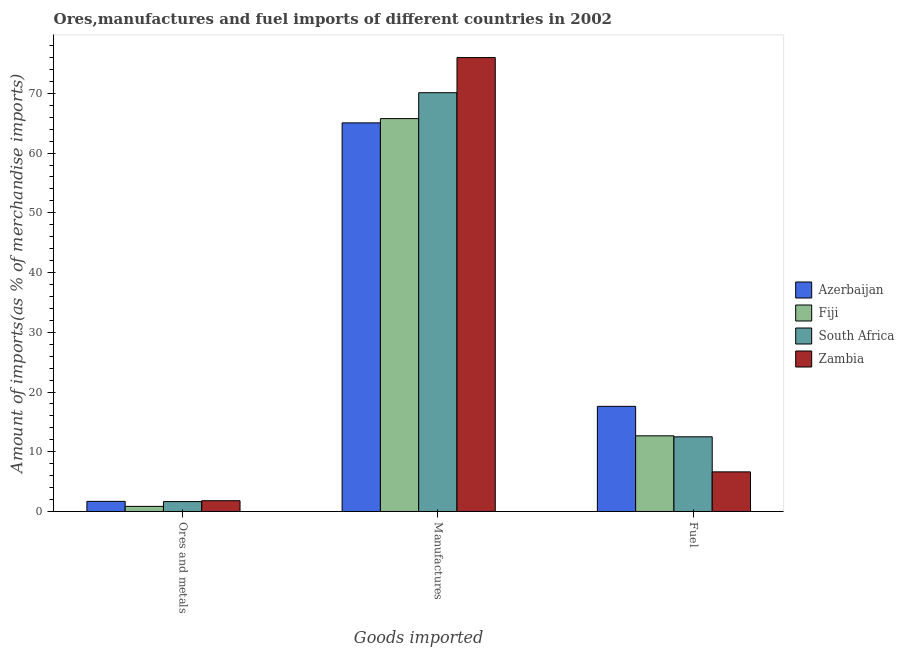How many bars are there on the 2nd tick from the left?
Provide a short and direct response. 4. How many bars are there on the 2nd tick from the right?
Provide a succinct answer. 4. What is the label of the 2nd group of bars from the left?
Your answer should be very brief. Manufactures. What is the percentage of fuel imports in Azerbaijan?
Give a very brief answer. 17.6. Across all countries, what is the maximum percentage of fuel imports?
Give a very brief answer. 17.6. Across all countries, what is the minimum percentage of manufactures imports?
Your answer should be very brief. 65.06. In which country was the percentage of fuel imports maximum?
Your answer should be compact. Azerbaijan. In which country was the percentage of manufactures imports minimum?
Offer a very short reply. Azerbaijan. What is the total percentage of fuel imports in the graph?
Give a very brief answer. 49.4. What is the difference between the percentage of ores and metals imports in Fiji and that in South Africa?
Provide a short and direct response. -0.8. What is the difference between the percentage of ores and metals imports in South Africa and the percentage of manufactures imports in Zambia?
Offer a terse response. -74.33. What is the average percentage of manufactures imports per country?
Your answer should be very brief. 69.23. What is the difference between the percentage of ores and metals imports and percentage of manufactures imports in Zambia?
Keep it short and to the point. -74.18. In how many countries, is the percentage of fuel imports greater than 28 %?
Ensure brevity in your answer.  0. What is the ratio of the percentage of ores and metals imports in Azerbaijan to that in Zambia?
Give a very brief answer. 0.94. Is the percentage of ores and metals imports in Zambia less than that in Azerbaijan?
Keep it short and to the point. No. What is the difference between the highest and the second highest percentage of fuel imports?
Offer a terse response. 4.94. What is the difference between the highest and the lowest percentage of ores and metals imports?
Your answer should be compact. 0.95. Is the sum of the percentage of ores and metals imports in Azerbaijan and Fiji greater than the maximum percentage of manufactures imports across all countries?
Offer a terse response. No. What does the 4th bar from the left in Manufactures represents?
Provide a succinct answer. Zambia. What does the 1st bar from the right in Fuel represents?
Offer a terse response. Zambia. Is it the case that in every country, the sum of the percentage of ores and metals imports and percentage of manufactures imports is greater than the percentage of fuel imports?
Provide a short and direct response. Yes. What is the difference between two consecutive major ticks on the Y-axis?
Give a very brief answer. 10. Are the values on the major ticks of Y-axis written in scientific E-notation?
Offer a terse response. No. Does the graph contain any zero values?
Offer a terse response. No. Where does the legend appear in the graph?
Give a very brief answer. Center right. How many legend labels are there?
Make the answer very short. 4. What is the title of the graph?
Offer a terse response. Ores,manufactures and fuel imports of different countries in 2002. What is the label or title of the X-axis?
Keep it short and to the point. Goods imported. What is the label or title of the Y-axis?
Offer a terse response. Amount of imports(as % of merchandise imports). What is the Amount of imports(as % of merchandise imports) of Azerbaijan in Ores and metals?
Provide a short and direct response. 1.69. What is the Amount of imports(as % of merchandise imports) of Fiji in Ores and metals?
Your response must be concise. 0.86. What is the Amount of imports(as % of merchandise imports) in South Africa in Ores and metals?
Provide a short and direct response. 1.66. What is the Amount of imports(as % of merchandise imports) in Zambia in Ores and metals?
Provide a short and direct response. 1.8. What is the Amount of imports(as % of merchandise imports) of Azerbaijan in Manufactures?
Keep it short and to the point. 65.06. What is the Amount of imports(as % of merchandise imports) in Fiji in Manufactures?
Your response must be concise. 65.77. What is the Amount of imports(as % of merchandise imports) of South Africa in Manufactures?
Your answer should be very brief. 70.1. What is the Amount of imports(as % of merchandise imports) of Zambia in Manufactures?
Your answer should be very brief. 75.99. What is the Amount of imports(as % of merchandise imports) of Azerbaijan in Fuel?
Give a very brief answer. 17.6. What is the Amount of imports(as % of merchandise imports) in Fiji in Fuel?
Make the answer very short. 12.67. What is the Amount of imports(as % of merchandise imports) in South Africa in Fuel?
Offer a very short reply. 12.5. What is the Amount of imports(as % of merchandise imports) of Zambia in Fuel?
Make the answer very short. 6.63. Across all Goods imported, what is the maximum Amount of imports(as % of merchandise imports) in Azerbaijan?
Ensure brevity in your answer.  65.06. Across all Goods imported, what is the maximum Amount of imports(as % of merchandise imports) in Fiji?
Provide a succinct answer. 65.77. Across all Goods imported, what is the maximum Amount of imports(as % of merchandise imports) in South Africa?
Keep it short and to the point. 70.1. Across all Goods imported, what is the maximum Amount of imports(as % of merchandise imports) in Zambia?
Your answer should be very brief. 75.99. Across all Goods imported, what is the minimum Amount of imports(as % of merchandise imports) of Azerbaijan?
Ensure brevity in your answer.  1.69. Across all Goods imported, what is the minimum Amount of imports(as % of merchandise imports) of Fiji?
Your answer should be compact. 0.86. Across all Goods imported, what is the minimum Amount of imports(as % of merchandise imports) of South Africa?
Ensure brevity in your answer.  1.66. Across all Goods imported, what is the minimum Amount of imports(as % of merchandise imports) of Zambia?
Ensure brevity in your answer.  1.8. What is the total Amount of imports(as % of merchandise imports) of Azerbaijan in the graph?
Offer a very short reply. 84.35. What is the total Amount of imports(as % of merchandise imports) of Fiji in the graph?
Your answer should be compact. 79.3. What is the total Amount of imports(as % of merchandise imports) in South Africa in the graph?
Offer a terse response. 84.26. What is the total Amount of imports(as % of merchandise imports) in Zambia in the graph?
Give a very brief answer. 84.42. What is the difference between the Amount of imports(as % of merchandise imports) of Azerbaijan in Ores and metals and that in Manufactures?
Provide a short and direct response. -63.36. What is the difference between the Amount of imports(as % of merchandise imports) in Fiji in Ores and metals and that in Manufactures?
Your answer should be very brief. -64.91. What is the difference between the Amount of imports(as % of merchandise imports) in South Africa in Ores and metals and that in Manufactures?
Provide a short and direct response. -68.45. What is the difference between the Amount of imports(as % of merchandise imports) in Zambia in Ores and metals and that in Manufactures?
Offer a very short reply. -74.18. What is the difference between the Amount of imports(as % of merchandise imports) of Azerbaijan in Ores and metals and that in Fuel?
Your answer should be compact. -15.91. What is the difference between the Amount of imports(as % of merchandise imports) in Fiji in Ores and metals and that in Fuel?
Keep it short and to the point. -11.81. What is the difference between the Amount of imports(as % of merchandise imports) of South Africa in Ores and metals and that in Fuel?
Make the answer very short. -10.84. What is the difference between the Amount of imports(as % of merchandise imports) of Zambia in Ores and metals and that in Fuel?
Provide a short and direct response. -4.83. What is the difference between the Amount of imports(as % of merchandise imports) of Azerbaijan in Manufactures and that in Fuel?
Your answer should be very brief. 47.45. What is the difference between the Amount of imports(as % of merchandise imports) of Fiji in Manufactures and that in Fuel?
Provide a succinct answer. 53.11. What is the difference between the Amount of imports(as % of merchandise imports) of South Africa in Manufactures and that in Fuel?
Ensure brevity in your answer.  57.6. What is the difference between the Amount of imports(as % of merchandise imports) of Zambia in Manufactures and that in Fuel?
Your answer should be very brief. 69.36. What is the difference between the Amount of imports(as % of merchandise imports) in Azerbaijan in Ores and metals and the Amount of imports(as % of merchandise imports) in Fiji in Manufactures?
Make the answer very short. -64.08. What is the difference between the Amount of imports(as % of merchandise imports) in Azerbaijan in Ores and metals and the Amount of imports(as % of merchandise imports) in South Africa in Manufactures?
Your answer should be compact. -68.41. What is the difference between the Amount of imports(as % of merchandise imports) in Azerbaijan in Ores and metals and the Amount of imports(as % of merchandise imports) in Zambia in Manufactures?
Provide a succinct answer. -74.29. What is the difference between the Amount of imports(as % of merchandise imports) of Fiji in Ores and metals and the Amount of imports(as % of merchandise imports) of South Africa in Manufactures?
Ensure brevity in your answer.  -69.25. What is the difference between the Amount of imports(as % of merchandise imports) in Fiji in Ores and metals and the Amount of imports(as % of merchandise imports) in Zambia in Manufactures?
Ensure brevity in your answer.  -75.13. What is the difference between the Amount of imports(as % of merchandise imports) of South Africa in Ores and metals and the Amount of imports(as % of merchandise imports) of Zambia in Manufactures?
Offer a very short reply. -74.33. What is the difference between the Amount of imports(as % of merchandise imports) of Azerbaijan in Ores and metals and the Amount of imports(as % of merchandise imports) of Fiji in Fuel?
Give a very brief answer. -10.97. What is the difference between the Amount of imports(as % of merchandise imports) in Azerbaijan in Ores and metals and the Amount of imports(as % of merchandise imports) in South Africa in Fuel?
Give a very brief answer. -10.81. What is the difference between the Amount of imports(as % of merchandise imports) in Azerbaijan in Ores and metals and the Amount of imports(as % of merchandise imports) in Zambia in Fuel?
Offer a very short reply. -4.94. What is the difference between the Amount of imports(as % of merchandise imports) in Fiji in Ores and metals and the Amount of imports(as % of merchandise imports) in South Africa in Fuel?
Your response must be concise. -11.64. What is the difference between the Amount of imports(as % of merchandise imports) in Fiji in Ores and metals and the Amount of imports(as % of merchandise imports) in Zambia in Fuel?
Provide a succinct answer. -5.77. What is the difference between the Amount of imports(as % of merchandise imports) of South Africa in Ores and metals and the Amount of imports(as % of merchandise imports) of Zambia in Fuel?
Your answer should be compact. -4.97. What is the difference between the Amount of imports(as % of merchandise imports) in Azerbaijan in Manufactures and the Amount of imports(as % of merchandise imports) in Fiji in Fuel?
Make the answer very short. 52.39. What is the difference between the Amount of imports(as % of merchandise imports) in Azerbaijan in Manufactures and the Amount of imports(as % of merchandise imports) in South Africa in Fuel?
Keep it short and to the point. 52.55. What is the difference between the Amount of imports(as % of merchandise imports) of Azerbaijan in Manufactures and the Amount of imports(as % of merchandise imports) of Zambia in Fuel?
Provide a short and direct response. 58.42. What is the difference between the Amount of imports(as % of merchandise imports) in Fiji in Manufactures and the Amount of imports(as % of merchandise imports) in South Africa in Fuel?
Your answer should be very brief. 53.27. What is the difference between the Amount of imports(as % of merchandise imports) of Fiji in Manufactures and the Amount of imports(as % of merchandise imports) of Zambia in Fuel?
Keep it short and to the point. 59.14. What is the difference between the Amount of imports(as % of merchandise imports) in South Africa in Manufactures and the Amount of imports(as % of merchandise imports) in Zambia in Fuel?
Your answer should be compact. 63.47. What is the average Amount of imports(as % of merchandise imports) of Azerbaijan per Goods imported?
Your answer should be very brief. 28.12. What is the average Amount of imports(as % of merchandise imports) in Fiji per Goods imported?
Provide a short and direct response. 26.43. What is the average Amount of imports(as % of merchandise imports) of South Africa per Goods imported?
Offer a terse response. 28.09. What is the average Amount of imports(as % of merchandise imports) in Zambia per Goods imported?
Offer a terse response. 28.14. What is the difference between the Amount of imports(as % of merchandise imports) of Azerbaijan and Amount of imports(as % of merchandise imports) of Fiji in Ores and metals?
Give a very brief answer. 0.84. What is the difference between the Amount of imports(as % of merchandise imports) in Azerbaijan and Amount of imports(as % of merchandise imports) in South Africa in Ores and metals?
Your answer should be compact. 0.04. What is the difference between the Amount of imports(as % of merchandise imports) in Azerbaijan and Amount of imports(as % of merchandise imports) in Zambia in Ores and metals?
Your response must be concise. -0.11. What is the difference between the Amount of imports(as % of merchandise imports) in Fiji and Amount of imports(as % of merchandise imports) in South Africa in Ores and metals?
Offer a very short reply. -0.8. What is the difference between the Amount of imports(as % of merchandise imports) in Fiji and Amount of imports(as % of merchandise imports) in Zambia in Ores and metals?
Offer a very short reply. -0.95. What is the difference between the Amount of imports(as % of merchandise imports) in South Africa and Amount of imports(as % of merchandise imports) in Zambia in Ores and metals?
Your answer should be very brief. -0.15. What is the difference between the Amount of imports(as % of merchandise imports) in Azerbaijan and Amount of imports(as % of merchandise imports) in Fiji in Manufactures?
Your answer should be compact. -0.72. What is the difference between the Amount of imports(as % of merchandise imports) of Azerbaijan and Amount of imports(as % of merchandise imports) of South Africa in Manufactures?
Ensure brevity in your answer.  -5.05. What is the difference between the Amount of imports(as % of merchandise imports) of Azerbaijan and Amount of imports(as % of merchandise imports) of Zambia in Manufactures?
Keep it short and to the point. -10.93. What is the difference between the Amount of imports(as % of merchandise imports) of Fiji and Amount of imports(as % of merchandise imports) of South Africa in Manufactures?
Provide a short and direct response. -4.33. What is the difference between the Amount of imports(as % of merchandise imports) of Fiji and Amount of imports(as % of merchandise imports) of Zambia in Manufactures?
Offer a very short reply. -10.22. What is the difference between the Amount of imports(as % of merchandise imports) of South Africa and Amount of imports(as % of merchandise imports) of Zambia in Manufactures?
Provide a succinct answer. -5.88. What is the difference between the Amount of imports(as % of merchandise imports) of Azerbaijan and Amount of imports(as % of merchandise imports) of Fiji in Fuel?
Your answer should be compact. 4.94. What is the difference between the Amount of imports(as % of merchandise imports) in Azerbaijan and Amount of imports(as % of merchandise imports) in South Africa in Fuel?
Ensure brevity in your answer.  5.1. What is the difference between the Amount of imports(as % of merchandise imports) of Azerbaijan and Amount of imports(as % of merchandise imports) of Zambia in Fuel?
Offer a very short reply. 10.97. What is the difference between the Amount of imports(as % of merchandise imports) of Fiji and Amount of imports(as % of merchandise imports) of South Africa in Fuel?
Provide a short and direct response. 0.16. What is the difference between the Amount of imports(as % of merchandise imports) in Fiji and Amount of imports(as % of merchandise imports) in Zambia in Fuel?
Give a very brief answer. 6.03. What is the difference between the Amount of imports(as % of merchandise imports) of South Africa and Amount of imports(as % of merchandise imports) of Zambia in Fuel?
Your response must be concise. 5.87. What is the ratio of the Amount of imports(as % of merchandise imports) of Azerbaijan in Ores and metals to that in Manufactures?
Your answer should be compact. 0.03. What is the ratio of the Amount of imports(as % of merchandise imports) in Fiji in Ores and metals to that in Manufactures?
Your answer should be compact. 0.01. What is the ratio of the Amount of imports(as % of merchandise imports) of South Africa in Ores and metals to that in Manufactures?
Offer a very short reply. 0.02. What is the ratio of the Amount of imports(as % of merchandise imports) in Zambia in Ores and metals to that in Manufactures?
Offer a very short reply. 0.02. What is the ratio of the Amount of imports(as % of merchandise imports) in Azerbaijan in Ores and metals to that in Fuel?
Your answer should be very brief. 0.1. What is the ratio of the Amount of imports(as % of merchandise imports) of Fiji in Ores and metals to that in Fuel?
Offer a terse response. 0.07. What is the ratio of the Amount of imports(as % of merchandise imports) of South Africa in Ores and metals to that in Fuel?
Your answer should be very brief. 0.13. What is the ratio of the Amount of imports(as % of merchandise imports) in Zambia in Ores and metals to that in Fuel?
Your answer should be compact. 0.27. What is the ratio of the Amount of imports(as % of merchandise imports) in Azerbaijan in Manufactures to that in Fuel?
Your response must be concise. 3.7. What is the ratio of the Amount of imports(as % of merchandise imports) in Fiji in Manufactures to that in Fuel?
Make the answer very short. 5.19. What is the ratio of the Amount of imports(as % of merchandise imports) in South Africa in Manufactures to that in Fuel?
Ensure brevity in your answer.  5.61. What is the ratio of the Amount of imports(as % of merchandise imports) of Zambia in Manufactures to that in Fuel?
Keep it short and to the point. 11.46. What is the difference between the highest and the second highest Amount of imports(as % of merchandise imports) in Azerbaijan?
Your answer should be very brief. 47.45. What is the difference between the highest and the second highest Amount of imports(as % of merchandise imports) in Fiji?
Your answer should be compact. 53.11. What is the difference between the highest and the second highest Amount of imports(as % of merchandise imports) of South Africa?
Keep it short and to the point. 57.6. What is the difference between the highest and the second highest Amount of imports(as % of merchandise imports) of Zambia?
Provide a succinct answer. 69.36. What is the difference between the highest and the lowest Amount of imports(as % of merchandise imports) of Azerbaijan?
Provide a short and direct response. 63.36. What is the difference between the highest and the lowest Amount of imports(as % of merchandise imports) in Fiji?
Your answer should be compact. 64.91. What is the difference between the highest and the lowest Amount of imports(as % of merchandise imports) of South Africa?
Your answer should be compact. 68.45. What is the difference between the highest and the lowest Amount of imports(as % of merchandise imports) of Zambia?
Give a very brief answer. 74.18. 